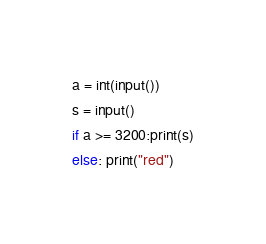<code> <loc_0><loc_0><loc_500><loc_500><_Python_>a = int(input())
s = input()
if a >= 3200:print(s)
else: print("red")</code> 